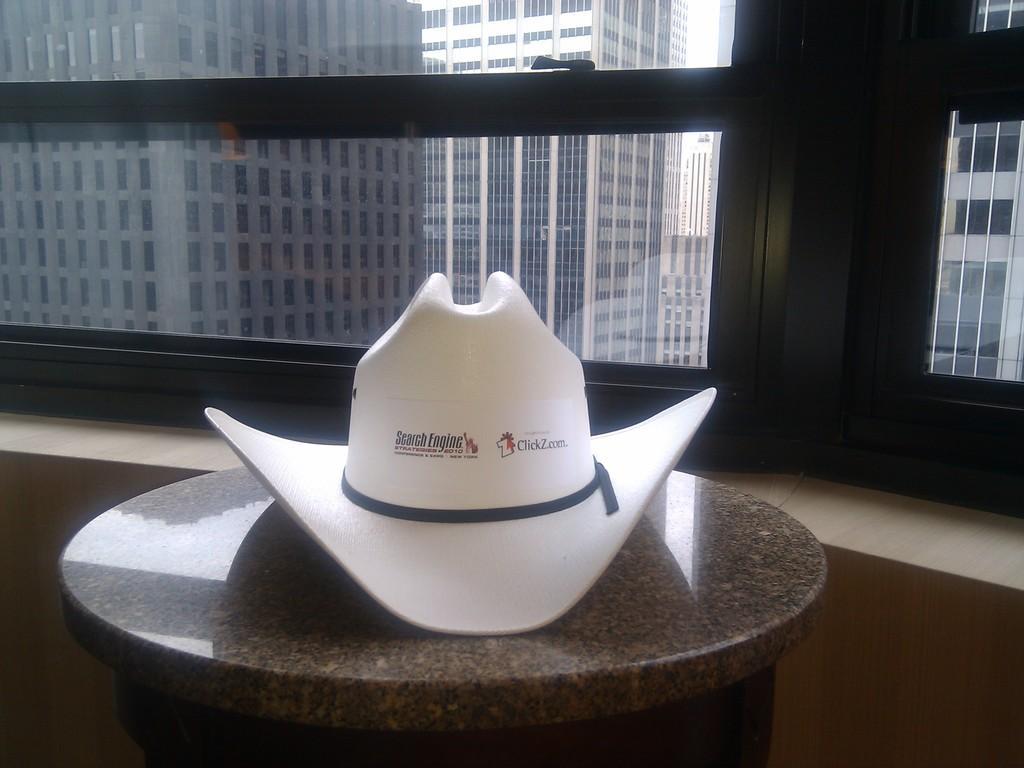Could you give a brief overview of what you see in this image? In the middle of this image, there is a white color cap placed on a table. Behind this table, there are glass windows. Through these glass windows, we can see there are buildings, which are having windows. 